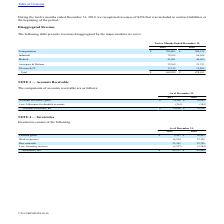From Cts Corporation's financial document, Which years does the table provide information for revenues disaggregated by the major markets the company ser ves? The document shows two values: 2019 and 2018. From the document: "2019 2018 2019 2018..." Also, What was the revenue from Industrial in 2019? According to the financial document, 78,369 (in thousands). The relevant text states: "Industrial 78,369 86,968..." Also, What was the revenue from Telecom & IT in 2018? According to the financial document, 19,405 (in thousands). The relevant text states: "Telecom & IT 17,155 19,405..." Additionally, Which major markets had revenues that exceeded $100,000 thousand in 2019? According to the financial document, Transportation. The relevant text states: "Transportation $ 299,005 $ 300,124..." Also, can you calculate: What was the change in the revenues from Aerospace & Defense between 2018 and 2019? Based on the calculation: 32,569-23,323, the result is 9246 (in thousands). This is based on the information: "Aerospace & Defense 32,569 23,323 Aerospace & Defense 32,569 23,323..." The key data points involved are: 23,323, 32,569. Also, can you calculate: What was the percentage change in total revenue between 2018 and 2019? To answer this question, I need to perform calculations using the financial data. The calculation is: (468,999-470,483)/470,483, which equals -0.32 (percentage). This is based on the information: "Total $ 468,999 $ 470,483 Total $ 468,999 $ 470,483..." The key data points involved are: 468,999, 470,483. 